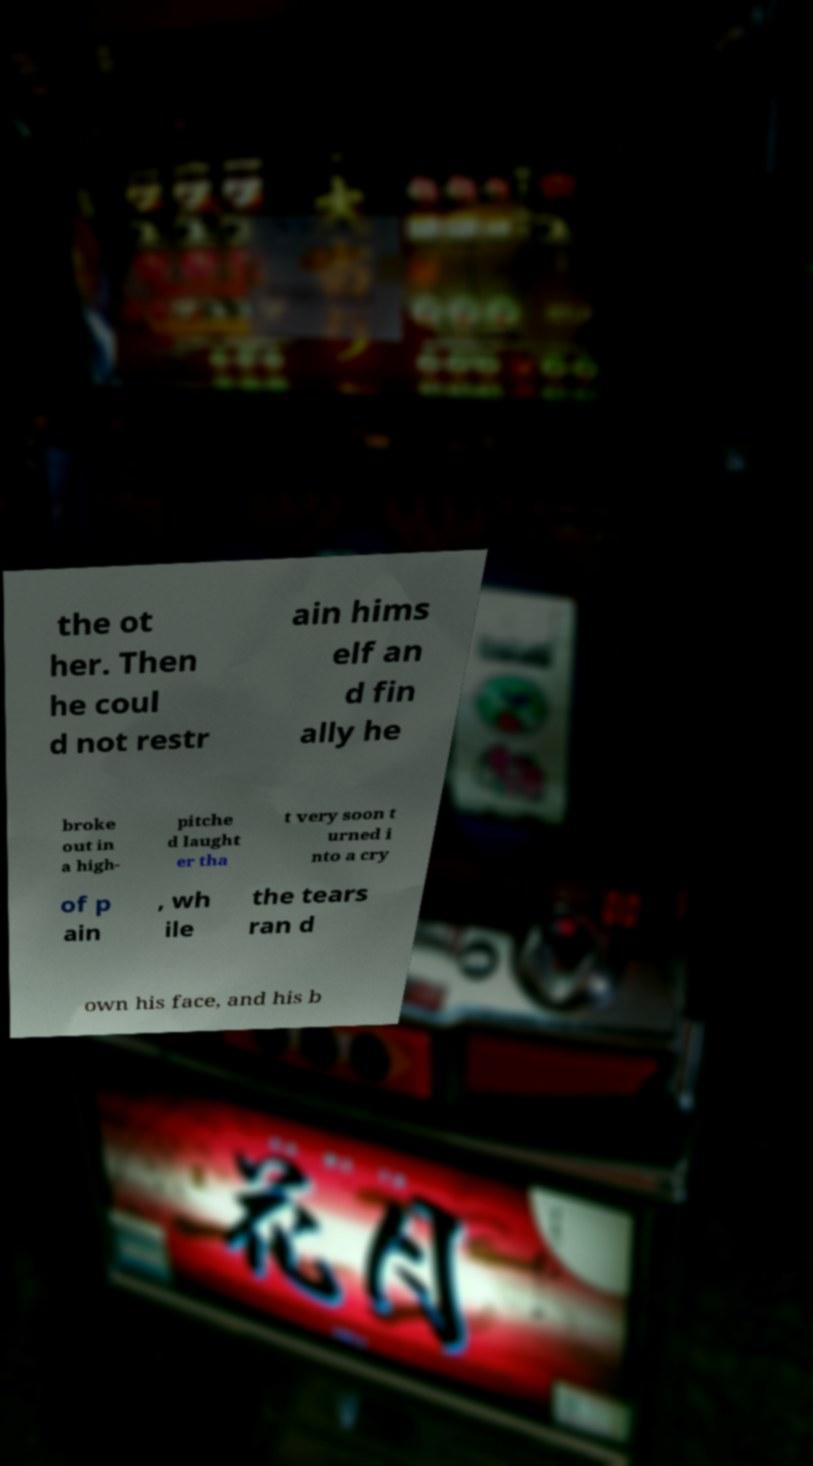What messages or text are displayed in this image? I need them in a readable, typed format. the ot her. Then he coul d not restr ain hims elf an d fin ally he broke out in a high- pitche d laught er tha t very soon t urned i nto a cry of p ain , wh ile the tears ran d own his face, and his b 